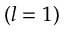<formula> <loc_0><loc_0><loc_500><loc_500>( l = 1 )</formula> 